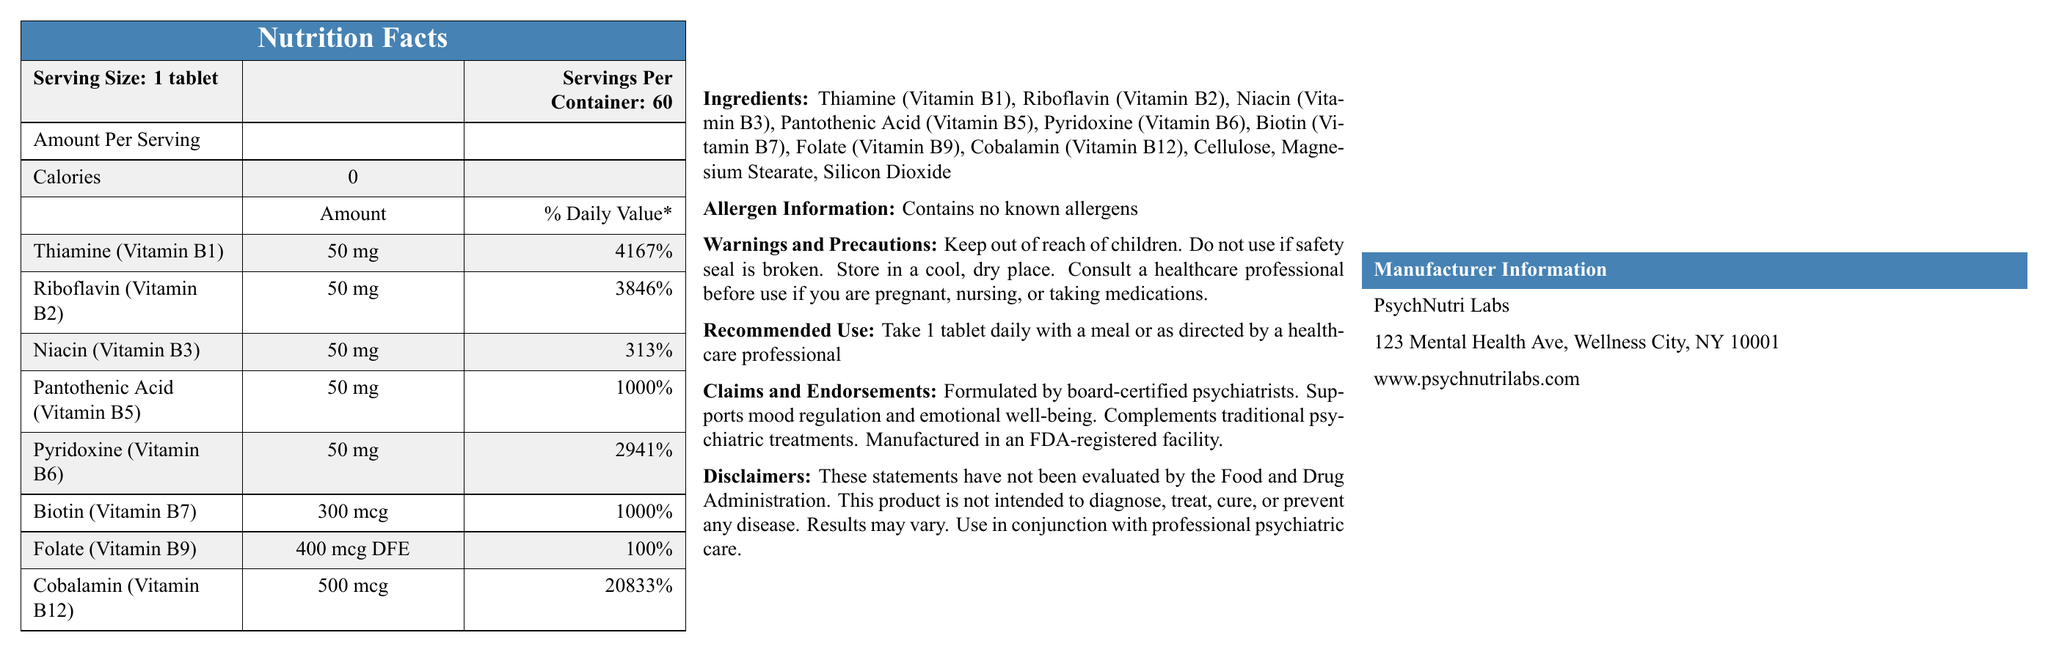what is the serving size of MoodBalance B-Complex? The document lists the serving size as "1 tablet".
Answer: 1 tablet how many servings are there per container? The document mentions that there are 60 servings per container.
Answer: 60 how many calories are there per serving? According to the document, each serving contains 0 calories.
Answer: 0 what is the amount of Thiamine (Vitamin B1) per serving? The document specifies that each serving contains 50 mg of Thiamine (Vitamin B1).
Answer: 50 mg what percentage of the daily value of Riboflavin (Vitamin B2) is provided per serving? The document states that the daily value percentage of Riboflavin (Vitamin B2) per serving is 3846%.
Answer: 3846% which vitamin has the highest % Daily Value? A. Thiamine (Vitamin B1) B. Pantothenic Acid (Vitamin B5) C. Cobalamin (Vitamin B12) D. Biotin (Vitamin B7) The % Daily Value of Cobalamin (Vitamin B12) is 20833%, which is the highest among the listed vitamins.
Answer: C. Cobalamin (Vitamin B12) what is the manufacturer's name? A. PsychNutri Labs B. Wellness Labs C. MentalHealth Supplements The document provides the manufacturer's name as PsychNutri Labs.
Answer: A. PsychNutri Labs does the product contain any known allergens? The allergen information section mentions that it contains no known allergens.
Answer: No is this supplement intended to diagnose, treat, cure, or prevent any disease? The document's disclaimer explicitly states that the product is not intended to diagnose, treat, cure, or prevent any disease.
Answer: No briefly summarize the main idea of the document. The document serves as a comprehensive source of information for consumers to understand what the supplement contains, its intended use, and the recommendations and warnings associated with it.
Answer: The document provides nutritional information about MoodBalance B-Complex, a vitamin B complex supplement endorsed for mood regulation. It outlines the serving size, ingredients, vitamin content, allergen information, warnings and precautions, recommended use, claims and endorsements, disclaimers, and manufacturer information. what is the purpose of this product according to the claims and endorsements section? The claims and endorsements section states that the product supports mood regulation and emotional well-being.
Answer: Supports mood regulation and emotional well-being what element should consumers be cautious about according to the warnings and precautions? The warnings and precautions advise consulting a healthcare professional before use if pregnant, nursing, or on medication.
Answer: Pregnant or nursing women, people taking medications where is PsychNutri Labs located? The document lists the address of PsychNutri Labs as 123 Mental Health Ave, Wellness City, NY 10001.
Answer: 123 Mental Health Ave, Wellness City, NY 10001 what is the recommended use for this product? The document's recommended use section advises taking 1 tablet daily with a meal or as directed by a healthcare professional.
Answer: Take 1 tablet daily with a meal or as directed by a healthcare professional is this product manufactured in an FDA-registered facility? The claims and endorsements section indicates that the product is manufactured in an FDA-registered facility.
Answer: Yes how much Folate (Vitamin B9) is in each serving? The document specifies that each serving contains 400 mcg DFE of Folate (Vitamin B9).
Answer: 400 mcg DFE who formulated MoodBalance B-Complex? The claims and endorsements section mentions that the product is formulated by board-certified psychiatrists.
Answer: Board-certified psychiatrists how many mg of Pyridoxine (Vitamin B6) are in each serving? The document lists the amount of Pyridoxine (Vitamin B6) per serving as 50 mg.
Answer: 50 mg what is the website of the manufacturer? The document provides the manufacturer's website as www.psychnutrilabs.com.
Answer: www.psychnutrilabs.com what are the inactive ingredients in this supplement? The ingredients list includes inactive ingredients such as Cellulose, Magnesium Stearate, and Silicon Dioxide.
Answer: Cellulose, Magnesium Stearate, Silicon Dioxide is the % Daily Value for Biotin (Vitamin B7) more than 1000%? The document states that the % Daily Value for Biotin (Vitamin B7) is exactly 1000%.
Answer: No what should you do if the safety seal is broken? The warnings and precautions section advises not to use the product if the safety seal is broken.
Answer: Do not use are the statements on the document evaluated by the Food and Drug Administration? The disclaimers section explicitly states that these statements have not been evaluated by the Food and Drug Administration.
Answer: No how effective is the product for every individual? The disclaimers section mentions that results may vary.
Answer: Results may vary what is the email address for customer support? The document does not provide an email address for customer support.
Answer: Cannot be determined 